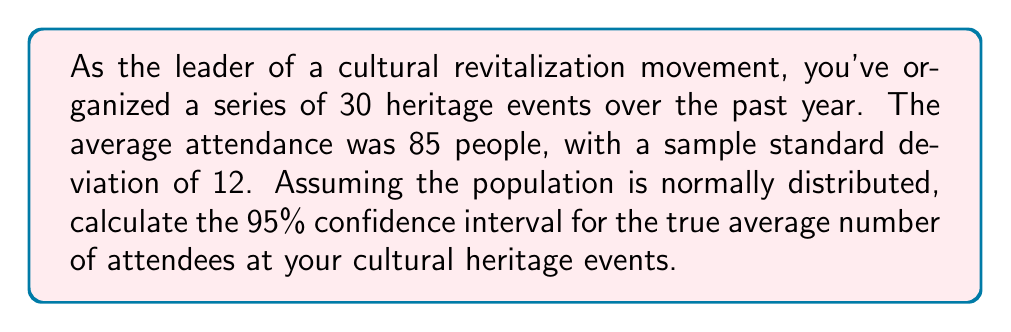Show me your answer to this math problem. To calculate the confidence interval, we'll follow these steps:

1. Identify the given information:
   - Sample size (n) = 30
   - Sample mean ($\bar{x}$) = 85
   - Sample standard deviation (s) = 12
   - Confidence level = 95%

2. Determine the critical value:
   For a 95% confidence interval with n = 30 (df = 29), we use the t-distribution.
   The critical value is $t_{0.025, 29} = 2.045$ (from t-table)

3. Calculate the standard error (SE) of the mean:
   $SE = \frac{s}{\sqrt{n}} = \frac{12}{\sqrt{30}} = 2.19$

4. Calculate the margin of error (ME):
   $ME = t_{0.025, 29} \times SE = 2.045 \times 2.19 = 4.48$

5. Compute the confidence interval:
   Lower bound: $\bar{x} - ME = 85 - 4.48 = 80.52$
   Upper bound: $\bar{x} + ME = 85 + 4.48 = 89.48$

Therefore, the 95% confidence interval is (80.52, 89.48).
Answer: (80.52, 89.48) 